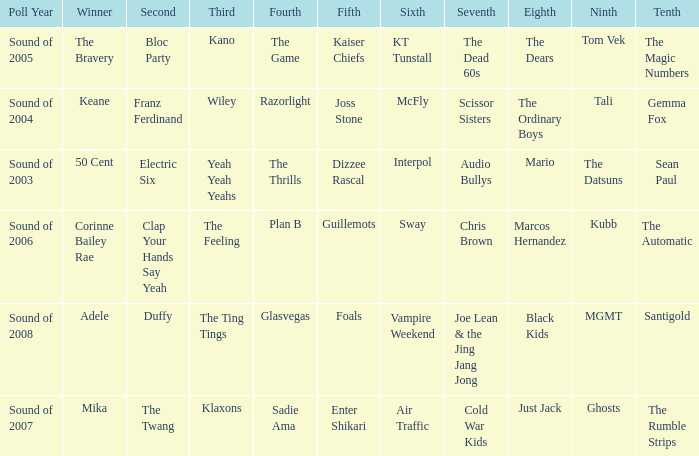Who was in 4th when in 6th is Air Traffic? Sadie Ama. 